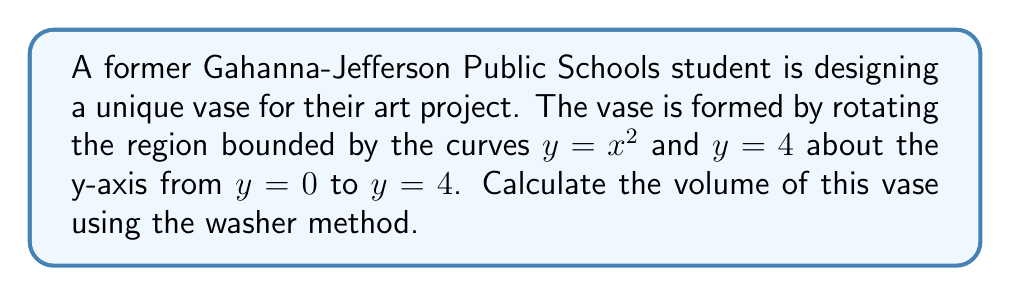Teach me how to tackle this problem. Let's approach this step-by-step using the washer method:

1) The washer method formula for volume when rotating around the y-axis is:

   $$V = \pi \int_a^b [(R(y))^2 - (r(y))^2] dy$$

   where $R(y)$ is the outer radius function and $r(y)$ is the inner radius function.

2) In this case, $y = x^2$ is the inner curve and $y = 4$ is the outer curve. We need to solve for $x$ in terms of $y$ for the inner curve:

   $y = x^2$
   $x = \sqrt{y}$

3) So, our radius functions are:
   $r(y) = \sqrt{y}$ (inner radius)
   $R(y) = 2$ (outer radius, constant)

4) Our limits of integration are from $y = 0$ to $y = 4$

5) Substituting into our volume formula:

   $$V = \pi \int_0^4 [2^2 - (\sqrt{y})^2] dy$$

6) Simplify:

   $$V = \pi \int_0^4 [4 - y] dy$$

7) Integrate:

   $$V = \pi [4y - \frac{1}{2}y^2]_0^4$$

8) Evaluate the integral:

   $$V = \pi [(4(4) - \frac{1}{2}(4)^2) - (4(0) - \frac{1}{2}(0)^2)]$$
   $$V = \pi [16 - 8 - 0]$$
   $$V = 8\pi$$

Therefore, the volume of the vase is $8\pi$ cubic units.
Answer: $8\pi$ cubic units 